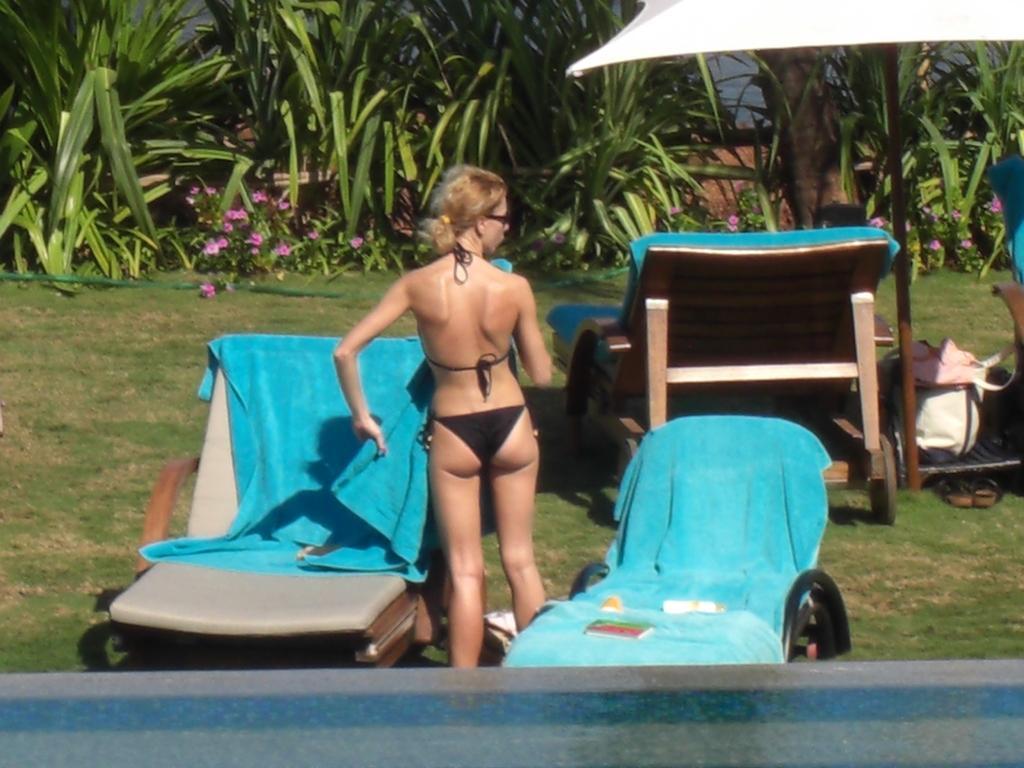Describe this image in one or two sentences. The women standing here is wearing a bikini and catching a blue towel in her left hand and there are trees in the background. 